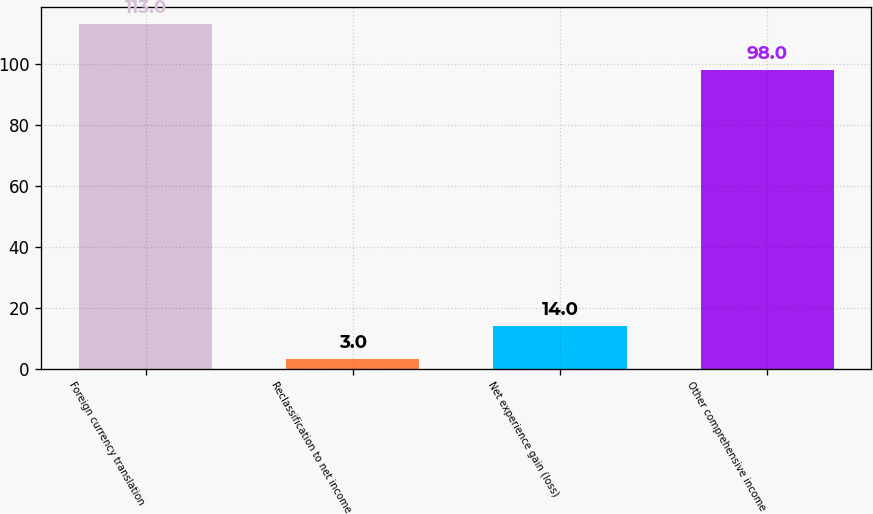Convert chart. <chart><loc_0><loc_0><loc_500><loc_500><bar_chart><fcel>Foreign currency translation<fcel>Reclassification to net income<fcel>Net experience gain (loss)<fcel>Other comprehensive income<nl><fcel>113<fcel>3<fcel>14<fcel>98<nl></chart> 